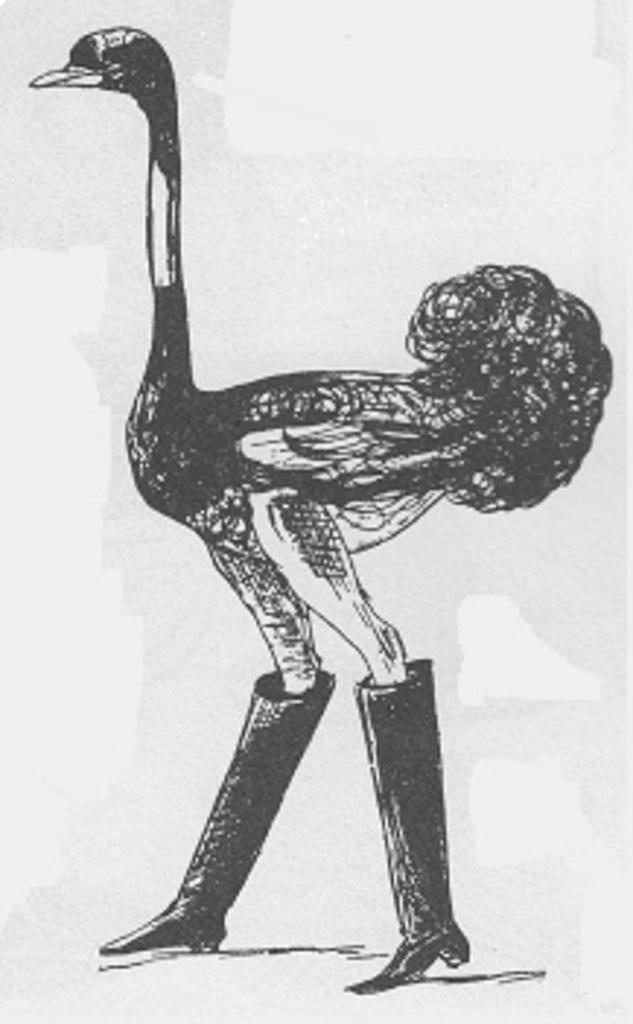What type of image is being described? The image is a drawing. What is the main subject of the drawing? There is an ostrich in the center of the drawing. Are there any unique features about the ostrich in the drawing? Yes, the ostrich is wearing shoes. What type of flesh can be seen on the ostrich in the drawing? There is no flesh visible on the ostrich in the drawing, as it is a drawing and not a photograph or real-life representation. 